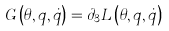Convert formula to latex. <formula><loc_0><loc_0><loc_500><loc_500>G \left ( \theta , q , \dot { q } \right ) = \partial _ { 3 } L \left ( \theta , q , \dot { q } \right )</formula> 